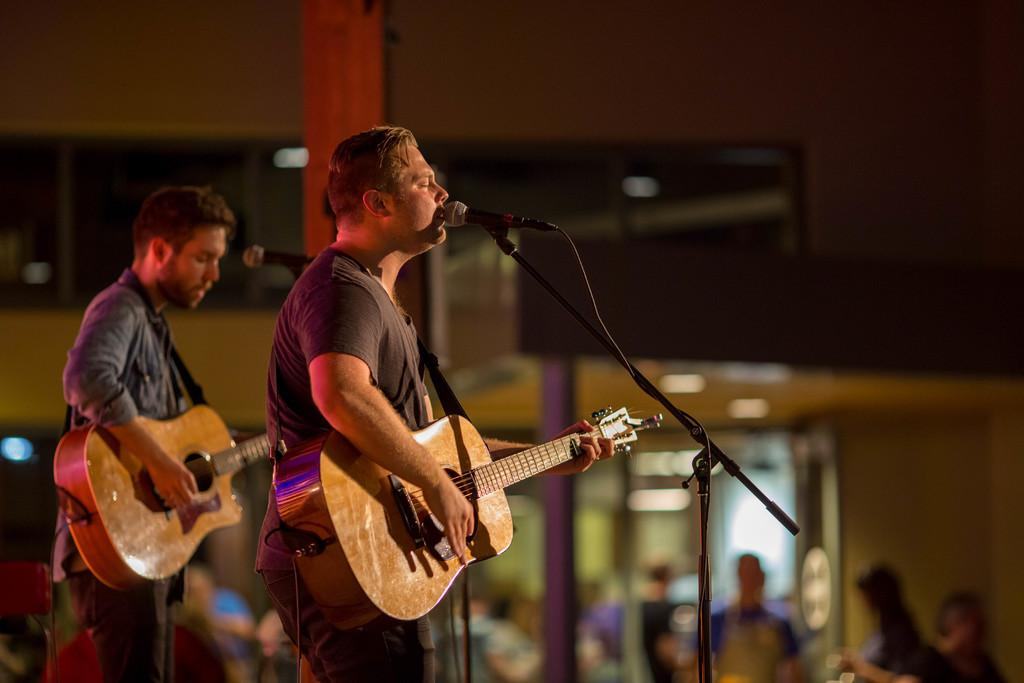How many people are present in the image? There are two persons in the image. What are the two persons doing? One person is playing a guitar, and the other person is singing. What equipment is visible in the image? There are microphones with stands in the image. What can be seen in the background of the image? There is a wall, other persons, and a pillar in the background. What type of trousers is the person playing the guitar wearing in the image? There is no information about the person's trousers in the image, so we cannot answer that question. Is there any coal visible in the image? No, there is no coal present in the image. 